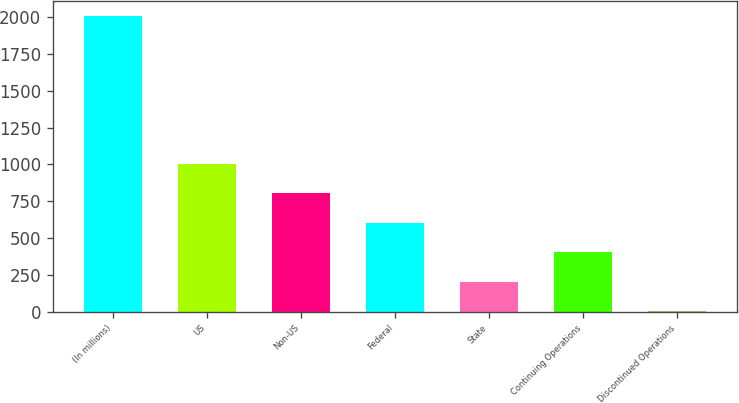Convert chart to OTSL. <chart><loc_0><loc_0><loc_500><loc_500><bar_chart><fcel>(In millions)<fcel>US<fcel>Non-US<fcel>Federal<fcel>State<fcel>Continuing Operations<fcel>Discontinued Operations<nl><fcel>2008<fcel>1005.75<fcel>805.3<fcel>604.85<fcel>203.95<fcel>404.4<fcel>3.5<nl></chart> 